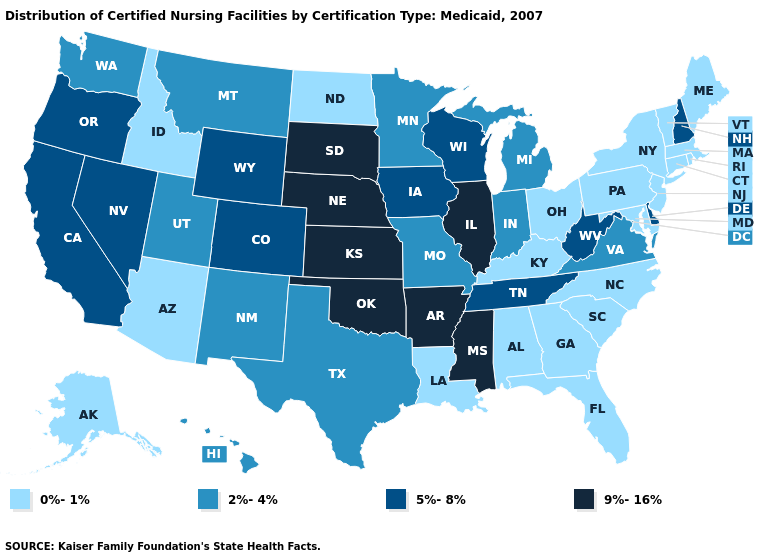Which states have the highest value in the USA?
Give a very brief answer. Arkansas, Illinois, Kansas, Mississippi, Nebraska, Oklahoma, South Dakota. Which states have the lowest value in the USA?
Be succinct. Alabama, Alaska, Arizona, Connecticut, Florida, Georgia, Idaho, Kentucky, Louisiana, Maine, Maryland, Massachusetts, New Jersey, New York, North Carolina, North Dakota, Ohio, Pennsylvania, Rhode Island, South Carolina, Vermont. Among the states that border Illinois , does Iowa have the lowest value?
Keep it brief. No. Does Massachusetts have the highest value in the USA?
Keep it brief. No. Name the states that have a value in the range 9%-16%?
Write a very short answer. Arkansas, Illinois, Kansas, Mississippi, Nebraska, Oklahoma, South Dakota. What is the highest value in the USA?
Short answer required. 9%-16%. What is the value of New Hampshire?
Keep it brief. 5%-8%. What is the highest value in the MidWest ?
Concise answer only. 9%-16%. Name the states that have a value in the range 9%-16%?
Quick response, please. Arkansas, Illinois, Kansas, Mississippi, Nebraska, Oklahoma, South Dakota. What is the value of Ohio?
Give a very brief answer. 0%-1%. Name the states that have a value in the range 9%-16%?
Be succinct. Arkansas, Illinois, Kansas, Mississippi, Nebraska, Oklahoma, South Dakota. Is the legend a continuous bar?
Give a very brief answer. No. What is the value of New Mexico?
Answer briefly. 2%-4%. What is the value of Arizona?
Answer briefly. 0%-1%. Which states have the lowest value in the West?
Be succinct. Alaska, Arizona, Idaho. 